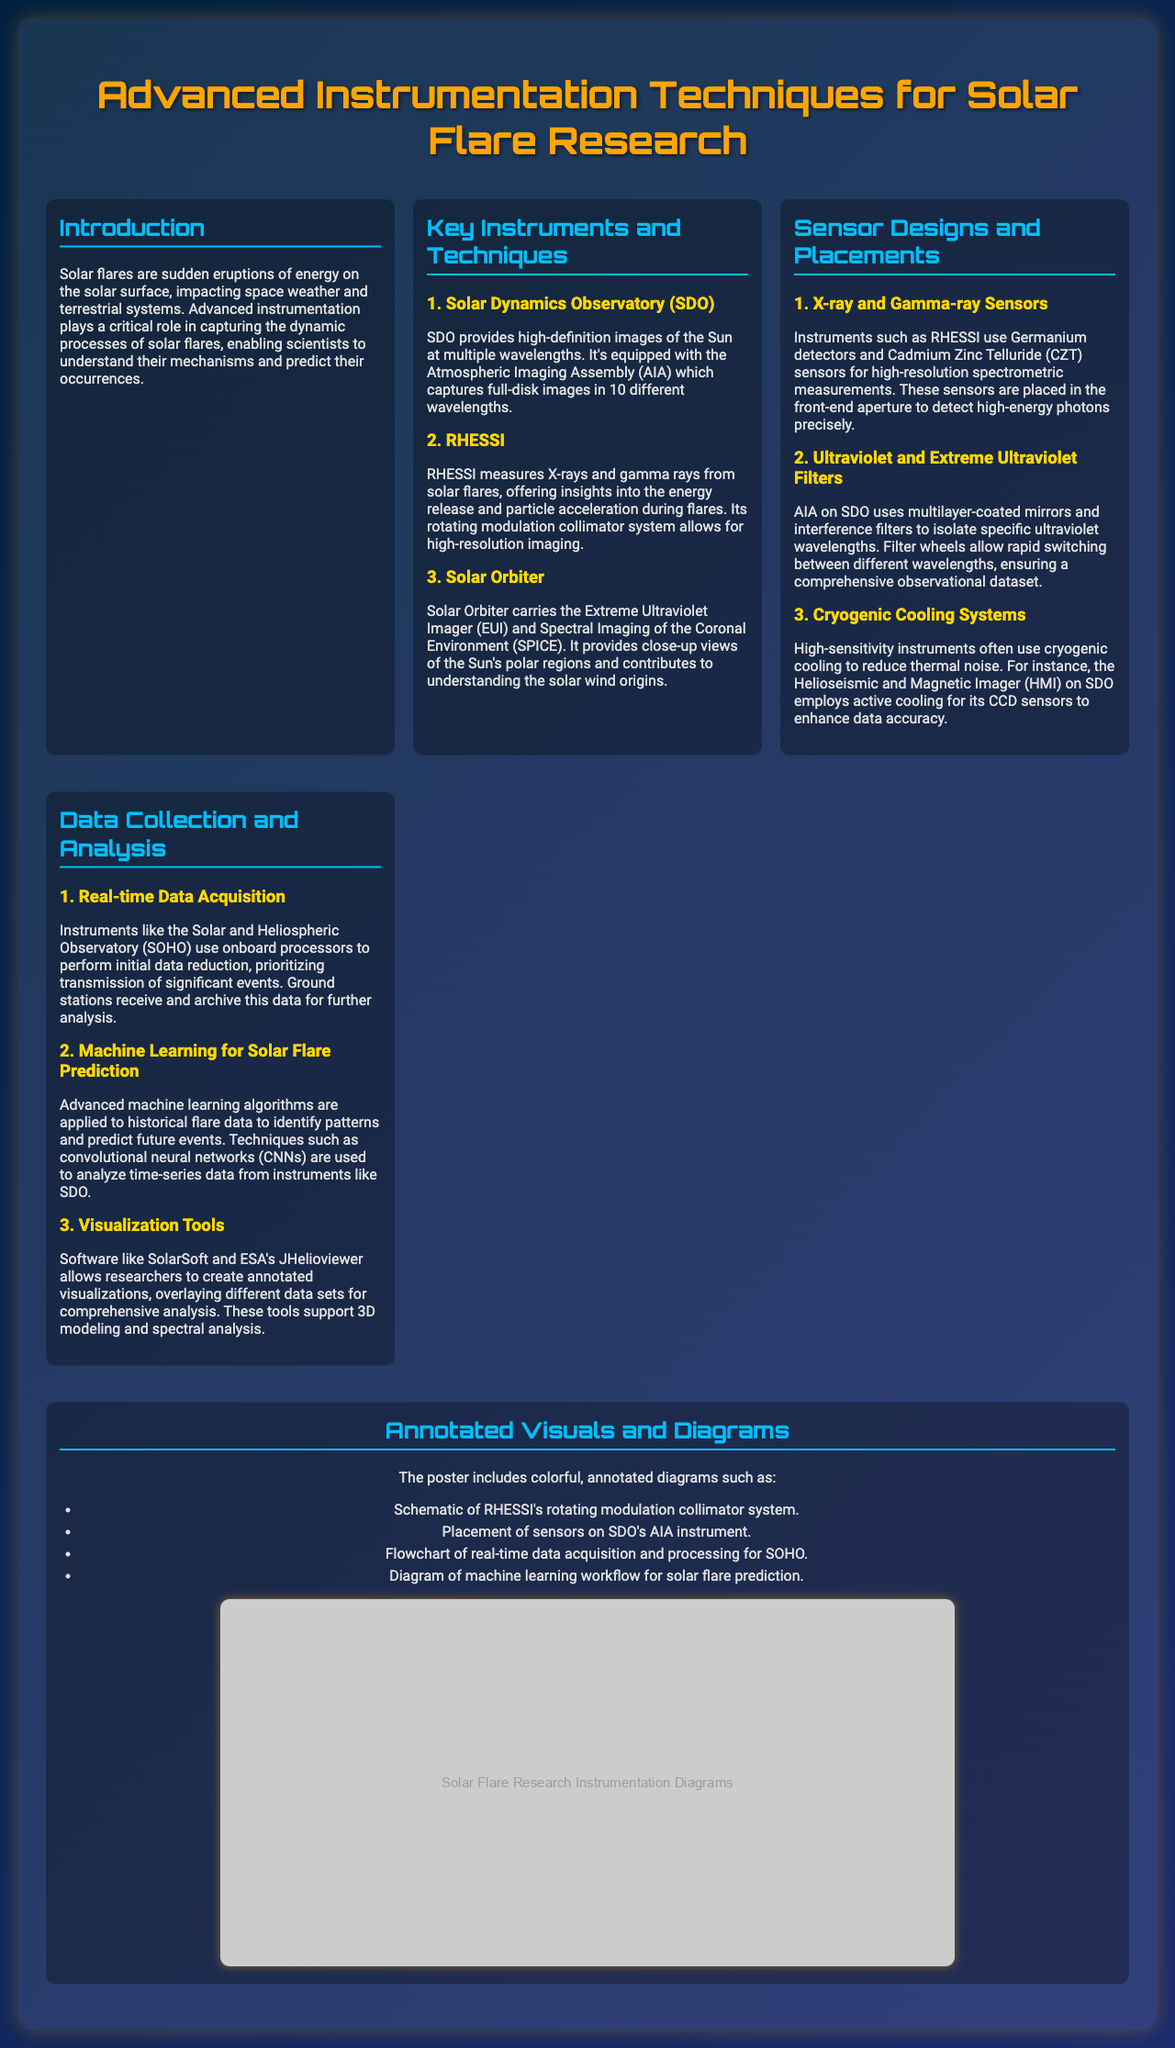What is the title of the poster? The title is prominently stated at the top of the poster as part of the header.
Answer: Advanced Instrumentation Techniques for Solar Flare Research What instrumentation is used by the Solar Dynamics Observatory? The specific instruments and capabilities are mentioned in the section detailing the Solar Dynamics Observatory.
Answer: Atmospheric Imaging Assembly Which technique does RHESSI employ for high-resolution imaging? This information is provided in the description of RHESSI's capabilities.
Answer: Rotating modulation collimator system What type of sensors are used by RHESSI? The types of sensors and their applications are explained in the section about sensor designs.
Answer: Germanium detectors and Cadmium Zinc Telluride What method is used for real-time data acquisition in SOHO? The passage mentions the system in place for managing data quickly, reflecting the operational efficiency of the instrument.
Answer: Onboard processors Which algorithm is mentioned for solar flare prediction? The document highlights advanced computational methods utilized in analysis and predictions, specifying the focus area.
Answer: Convolutional neural networks What type of visualization tools are mentioned in the document? The tools listed provide insight into data presentation and visualization techniques utilized by researchers.
Answer: SolarSoft and ESA's JHelioviewer How many wavelengths does AIA capture images in? The exact number of wavelengths mentioned gives specific context about the observational capabilities of AIA.
Answer: 10 different wavelengths 